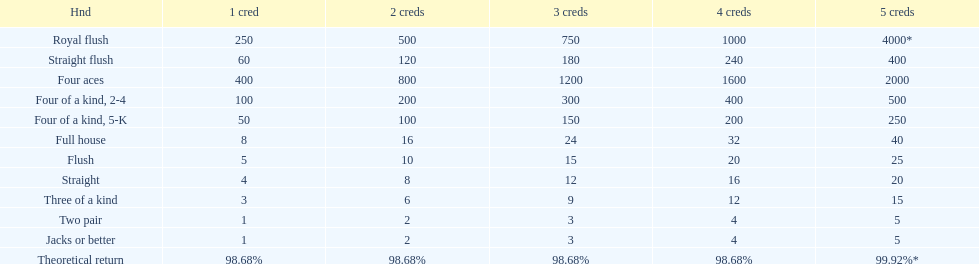At most, what could a person earn for having a full house? 40. I'm looking to parse the entire table for insights. Could you assist me with that? {'header': ['Hnd', '1 cred', '2 creds', '3 creds', '4 creds', '5 creds'], 'rows': [['Royal flush', '250', '500', '750', '1000', '4000*'], ['Straight flush', '60', '120', '180', '240', '400'], ['Four aces', '400', '800', '1200', '1600', '2000'], ['Four of a kind, 2-4', '100', '200', '300', '400', '500'], ['Four of a kind, 5-K', '50', '100', '150', '200', '250'], ['Full house', '8', '16', '24', '32', '40'], ['Flush', '5', '10', '15', '20', '25'], ['Straight', '4', '8', '12', '16', '20'], ['Three of a kind', '3', '6', '9', '12', '15'], ['Two pair', '1', '2', '3', '4', '5'], ['Jacks or better', '1', '2', '3', '4', '5'], ['Theoretical return', '98.68%', '98.68%', '98.68%', '98.68%', '99.92%*']]} 